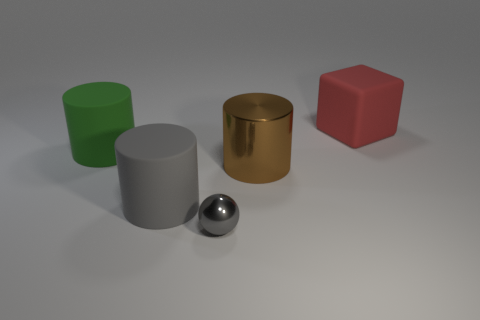The large object behind the big cylinder that is on the left side of the gray rubber cylinder that is right of the large green rubber object is what color?
Keep it short and to the point. Red. Is the material of the cylinder that is right of the tiny metallic sphere the same as the cylinder in front of the brown cylinder?
Provide a succinct answer. No. What is the shape of the large matte object to the right of the big gray matte thing?
Provide a succinct answer. Cube. How many things are either large shiny cylinders or cylinders to the right of the large gray thing?
Your answer should be very brief. 1. Is the material of the big gray thing the same as the big red cube?
Your answer should be compact. Yes. Are there an equal number of red rubber cubes in front of the big red block and large rubber objects that are left of the gray matte cylinder?
Your answer should be very brief. No. What number of red matte blocks are behind the big green cylinder?
Offer a terse response. 1. How many things are large red cubes or small gray metal cubes?
Offer a very short reply. 1. How many spheres have the same size as the red block?
Offer a very short reply. 0. The gray object that is in front of the gray object behind the small ball is what shape?
Give a very brief answer. Sphere. 